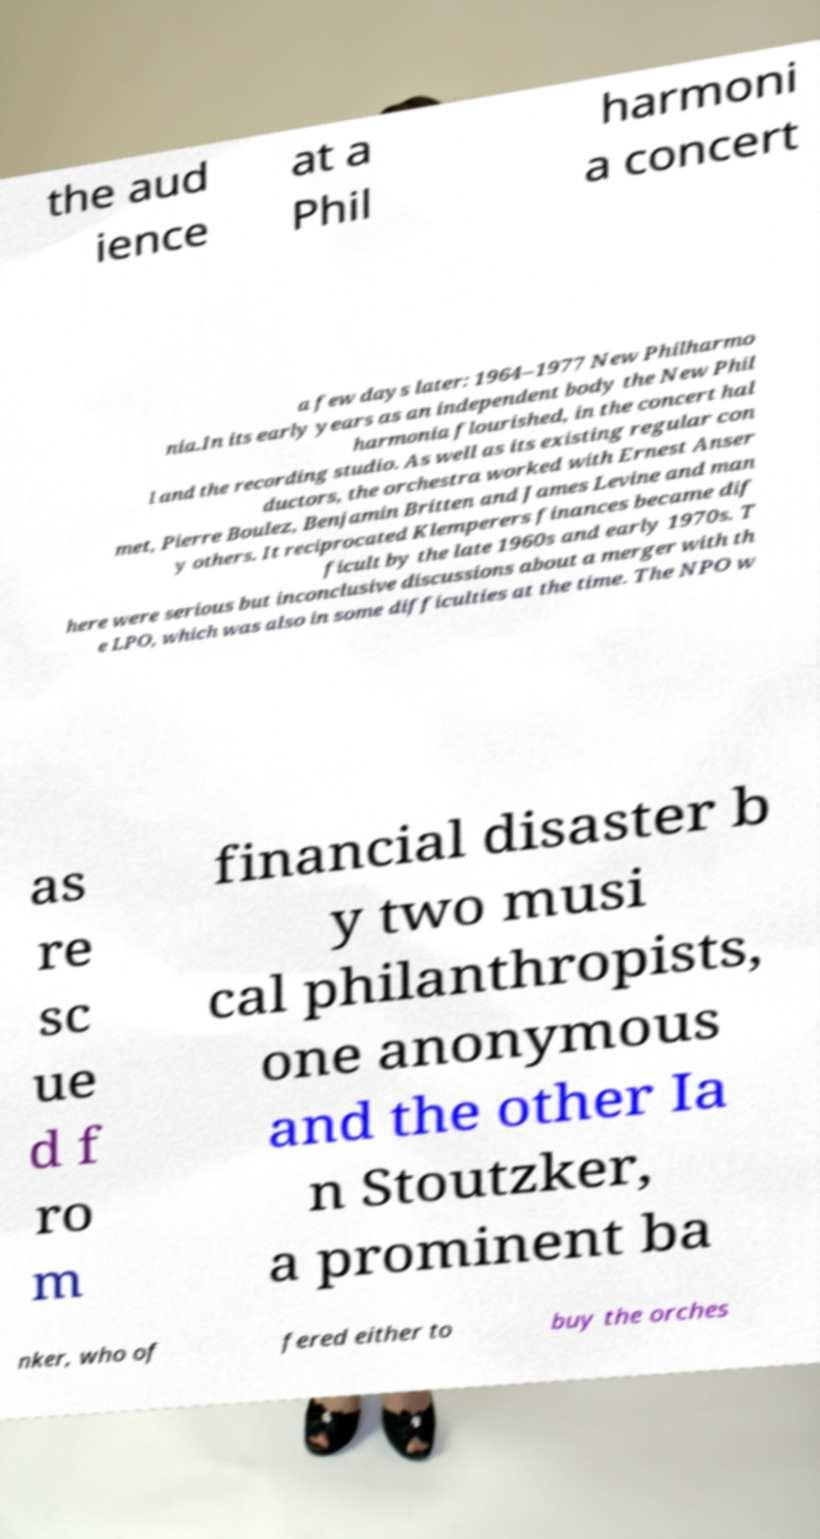Please identify and transcribe the text found in this image. the aud ience at a Phil harmoni a concert a few days later: 1964–1977 New Philharmo nia.In its early years as an independent body the New Phil harmonia flourished, in the concert hal l and the recording studio. As well as its existing regular con ductors, the orchestra worked with Ernest Anser met, Pierre Boulez, Benjamin Britten and James Levine and man y others. It reciprocated Klemperers finances became dif ficult by the late 1960s and early 1970s. T here were serious but inconclusive discussions about a merger with th e LPO, which was also in some difficulties at the time. The NPO w as re sc ue d f ro m financial disaster b y two musi cal philanthropists, one anonymous and the other Ia n Stoutzker, a prominent ba nker, who of fered either to buy the orches 